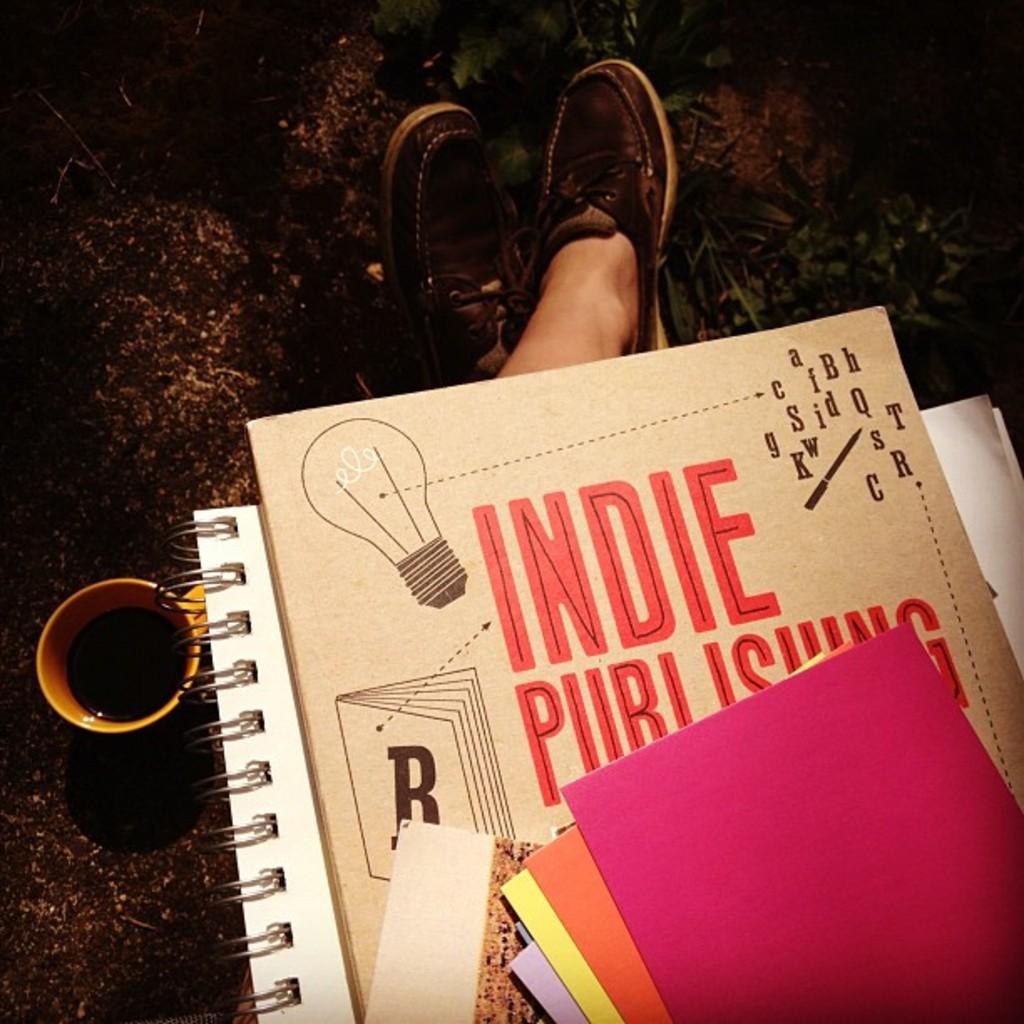What is the letter on the book on the book?
Offer a terse response. B. 